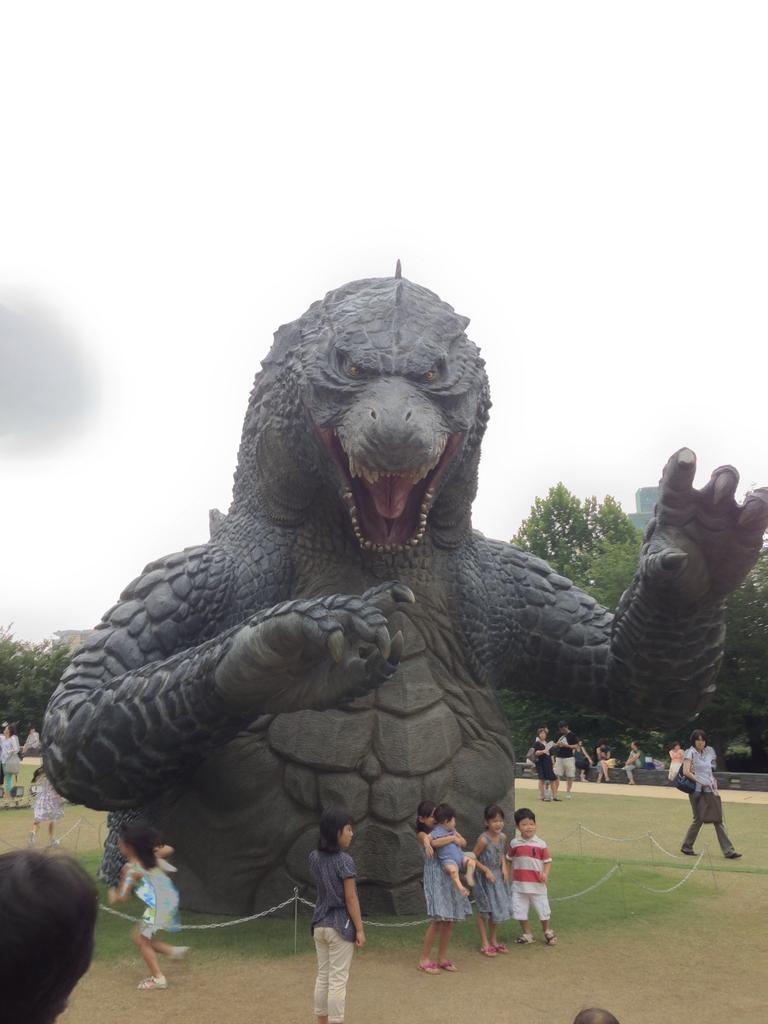Please provide a concise description of this image. In the image we can see a sculpture of an animal. There are even people around, standing and some of them are walking. They are wearing clothes, this is a sand, grass, trees and a white sky. 